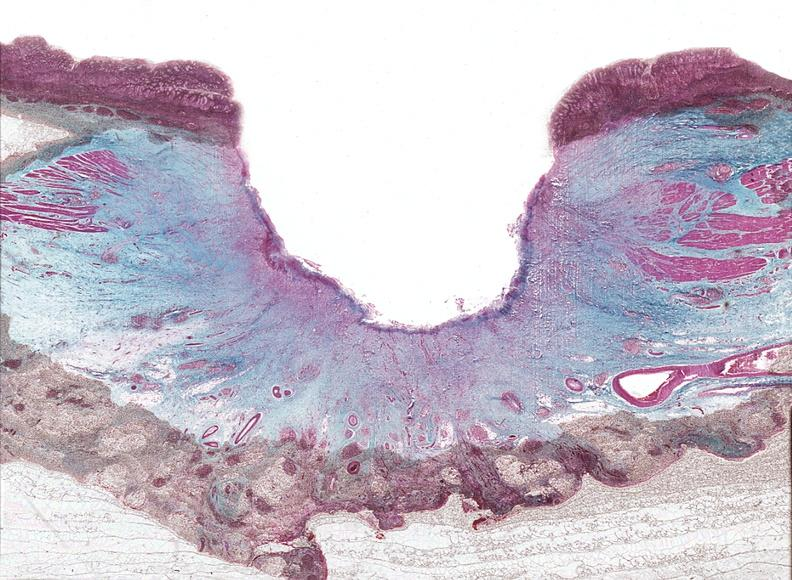what is present?
Answer the question using a single word or phrase. Gastrointestinal 